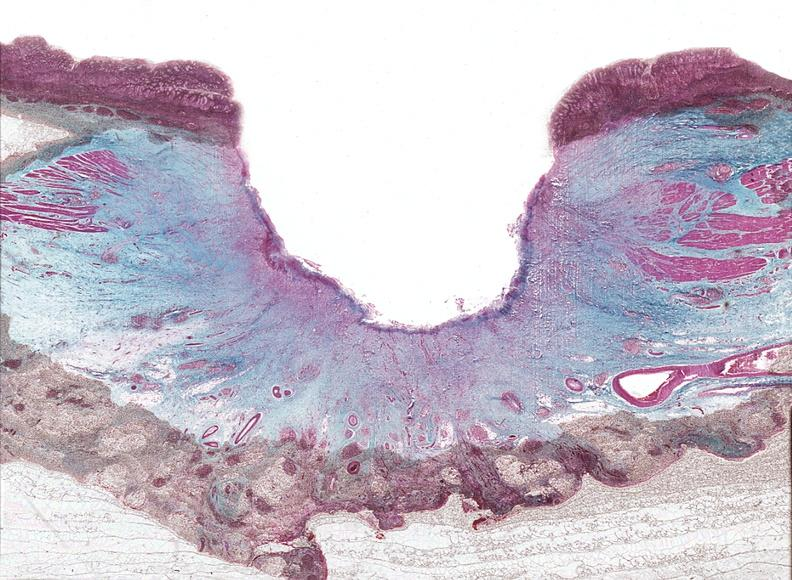what is present?
Answer the question using a single word or phrase. Gastrointestinal 